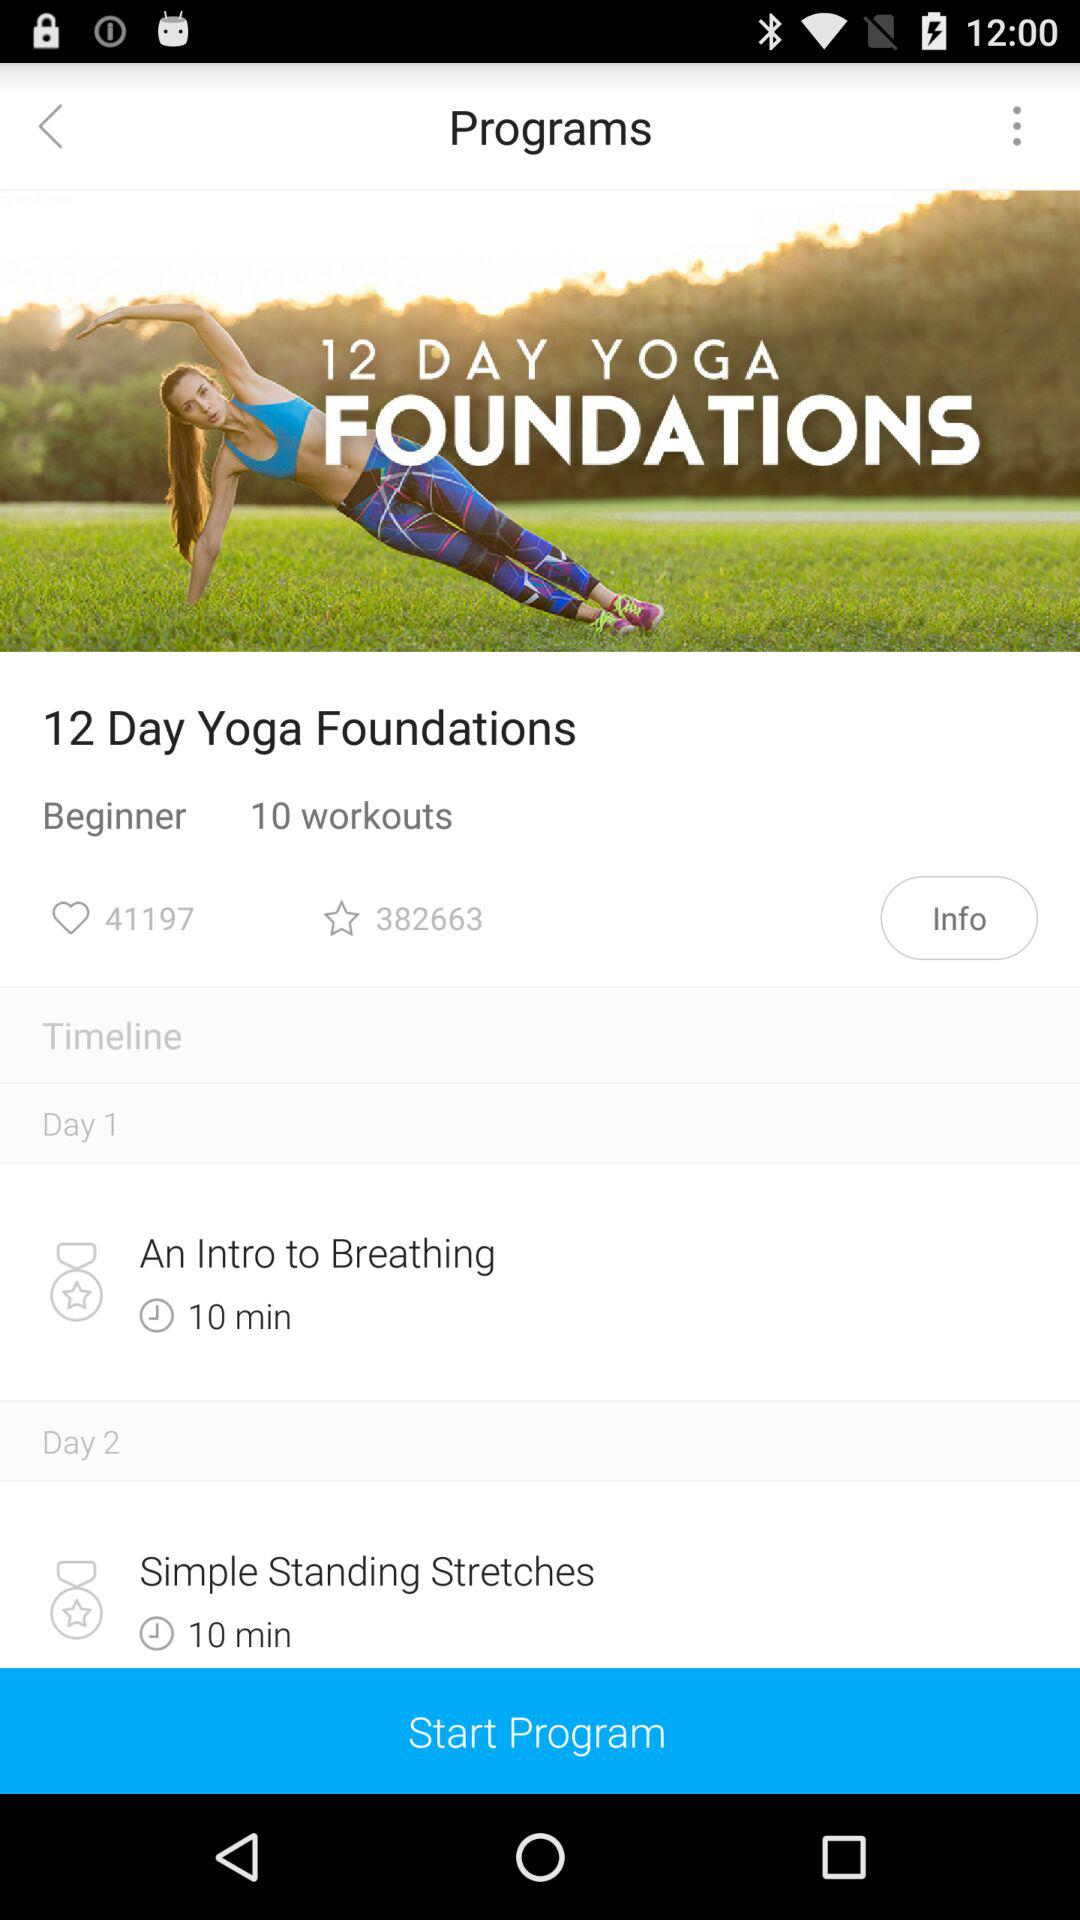What are the number of likes? The number of likes is 41197. 